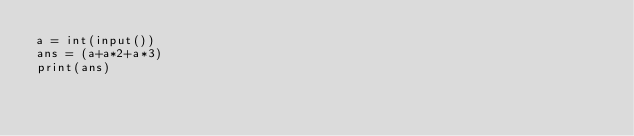Convert code to text. <code><loc_0><loc_0><loc_500><loc_500><_Python_>a = int(input())
ans = (a+a*2+a*3)
print(ans)
</code> 